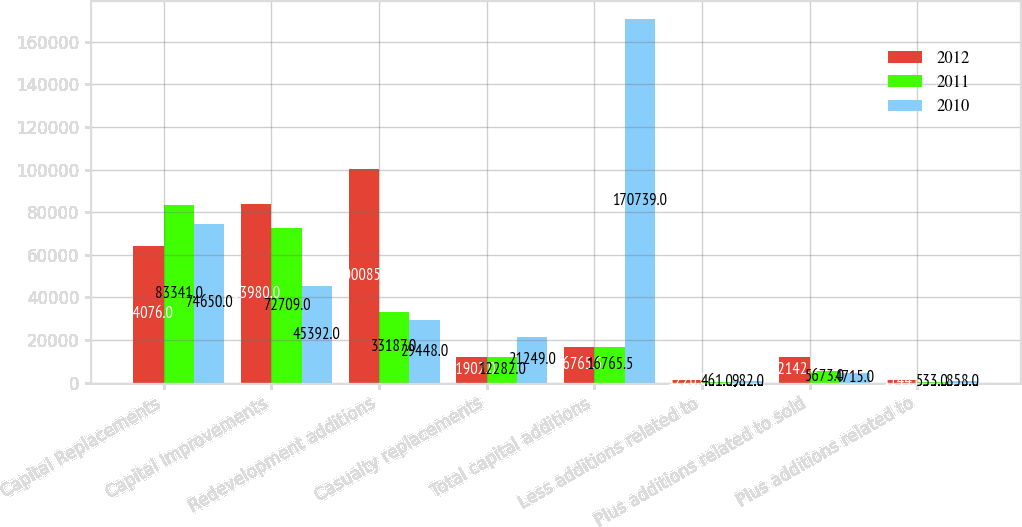<chart> <loc_0><loc_0><loc_500><loc_500><stacked_bar_chart><ecel><fcel>Capital Replacements<fcel>Capital Improvements<fcel>Redevelopment additions<fcel>Casualty replacements<fcel>Total capital additions<fcel>Less additions related to<fcel>Plus additions related to sold<fcel>Plus additions related to<nl><fcel>2012<fcel>64076<fcel>83980<fcel>100085<fcel>11902<fcel>16765.5<fcel>1226<fcel>12142<fcel>1144<nl><fcel>2011<fcel>83341<fcel>72709<fcel>33187<fcel>12282<fcel>16765.5<fcel>461<fcel>5673<fcel>533<nl><fcel>2010<fcel>74650<fcel>45392<fcel>29448<fcel>21249<fcel>170739<fcel>982<fcel>4715<fcel>858<nl></chart> 